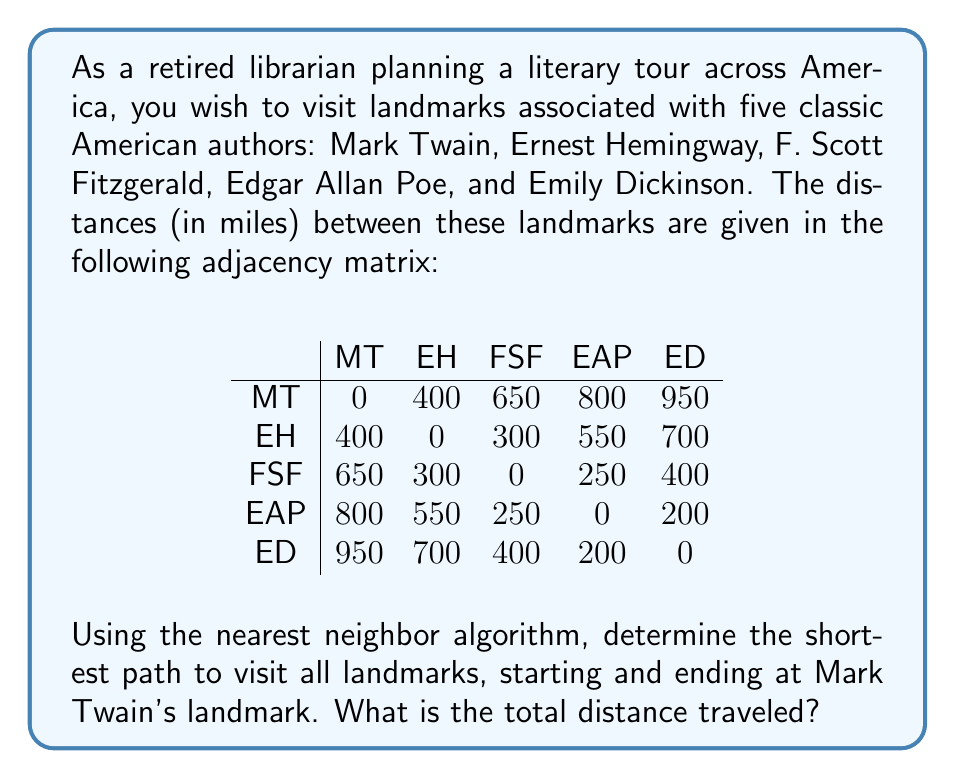Can you solve this math problem? To solve this problem using the nearest neighbor algorithm, we'll follow these steps:

1. Start at Mark Twain's landmark (MT).
2. From the current location, choose the nearest unvisited landmark.
3. Move to that landmark and mark it as visited.
4. Repeat steps 2-3 until all landmarks are visited.
5. Return to the starting point (MT).

Let's apply the algorithm:

1. Start at MT
2. Nearest to MT: EH (400 miles)
   Path: MT → EH, Distance: 400 miles
3. Nearest to EH (excluding MT): FSF (300 miles)
   Path: MT → EH → FSF, Distance: 400 + 300 = 700 miles
4. Nearest to FSF (excluding MT and EH): EAP (250 miles)
   Path: MT → EH → FSF → EAP, Distance: 700 + 250 = 950 miles
5. Only ED remains unvisited. Distance from EAP to ED: 200 miles
   Path: MT → EH → FSF → EAP → ED, Distance: 950 + 200 = 1150 miles
6. Return to MT from ED: 950 miles
   Final path: MT → EH → FSF → EAP → ED → MT
   Total distance: 1150 + 950 = 2100 miles

Therefore, the shortest path using the nearest neighbor algorithm is:
Mark Twain → Ernest Hemingway → F. Scott Fitzgerald → Edgar Allan Poe → Emily Dickinson → Mark Twain
Answer: The total distance traveled is 2100 miles. 